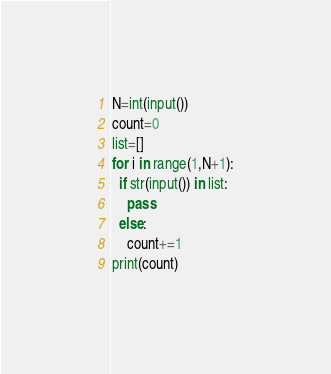<code> <loc_0><loc_0><loc_500><loc_500><_Python_>N=int(input())
count=0
list=[]
for i in range(1,N+1):
  if str(input()) in list:
    pass
  else:
    count+=1
print(count)</code> 